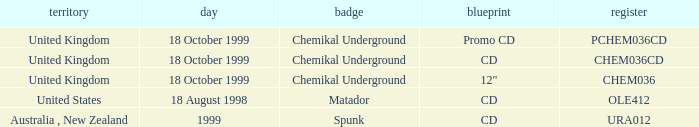What label has a catalog of chem036cd? Chemikal Underground. 